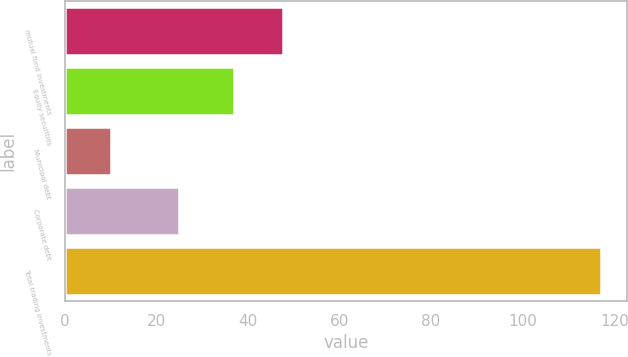<chart> <loc_0><loc_0><loc_500><loc_500><bar_chart><fcel>mutual fund investments<fcel>Equity securities<fcel>Municipal debt<fcel>Corporate debt<fcel>Total trading investments<nl><fcel>47.7<fcel>37<fcel>10<fcel>25<fcel>117<nl></chart> 